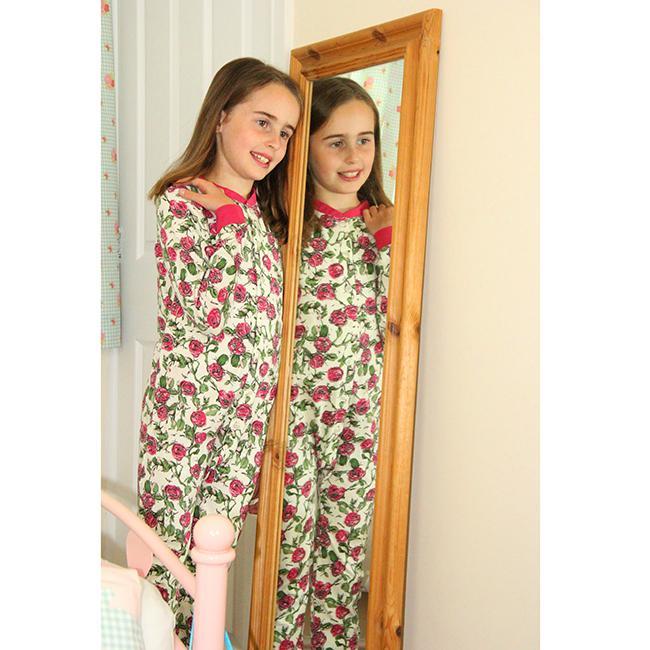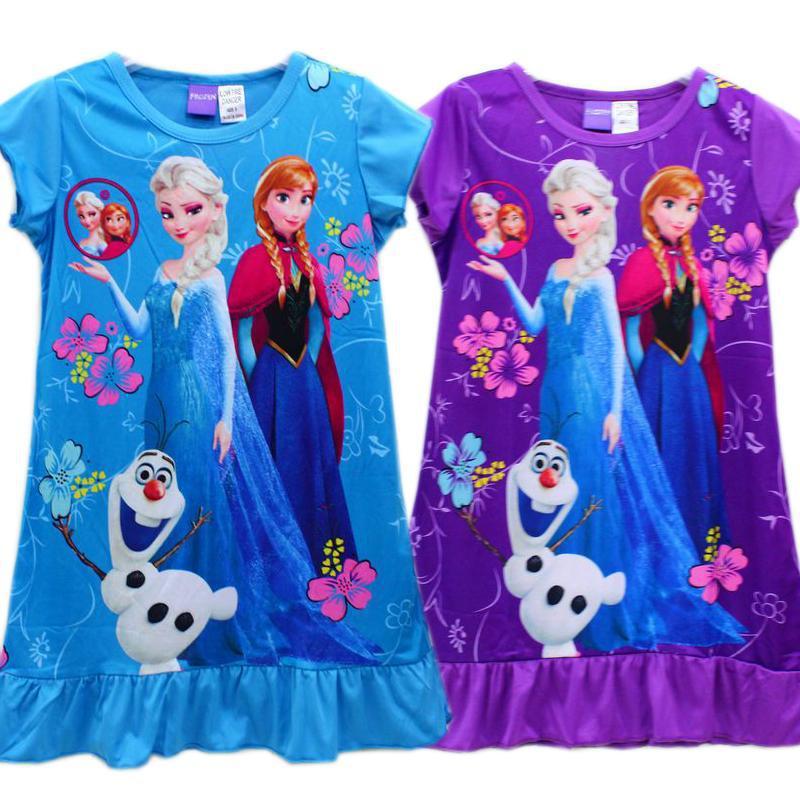The first image is the image on the left, the second image is the image on the right. For the images shown, is this caption "There are more kids in the image on the right than in the image on the left." true? Answer yes or no. No. The first image is the image on the left, the second image is the image on the right. For the images shown, is this caption "One image shows two sleepwear outfits that feature the face of a Disney princess-type character on the front." true? Answer yes or no. Yes. 